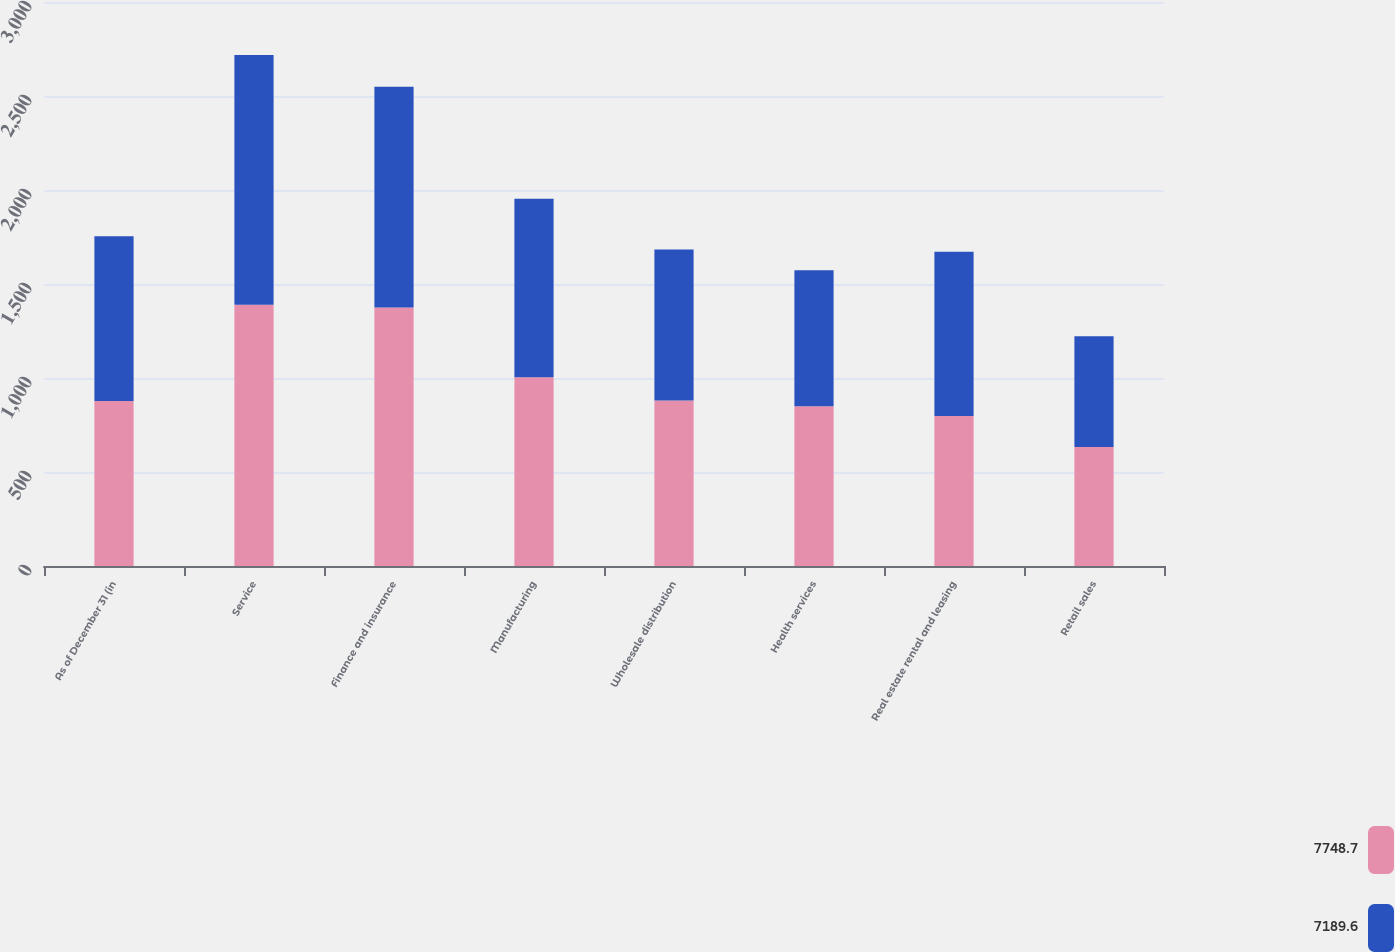<chart> <loc_0><loc_0><loc_500><loc_500><stacked_bar_chart><ecel><fcel>As of December 31 (in<fcel>Service<fcel>Finance and insurance<fcel>Manufacturing<fcel>Wholesale distribution<fcel>Health services<fcel>Real estate rental and leasing<fcel>Retail sales<nl><fcel>7748.7<fcel>877.05<fcel>1390.1<fcel>1374.9<fcel>1004.2<fcel>880.6<fcel>849.4<fcel>797.7<fcel>633<nl><fcel>7189.6<fcel>877.05<fcel>1328.5<fcel>1174.9<fcel>949.9<fcel>802.6<fcel>724<fcel>873.5<fcel>589<nl></chart> 